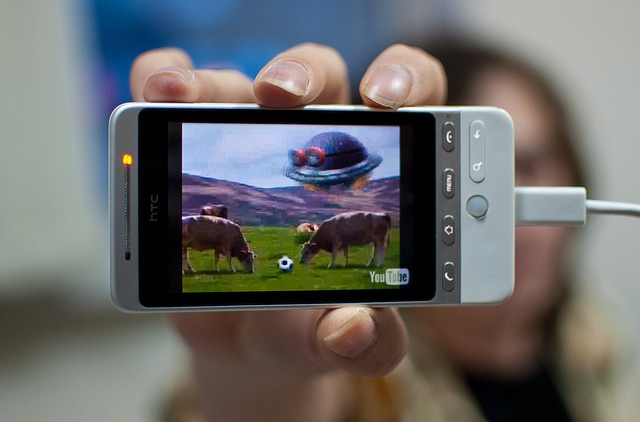Describe the objects in this image and their specific colors. I can see people in darkgray, maroon, gray, and black tones, cell phone in darkgray, black, gray, and darkgreen tones, cow in darkgray, black, darkgreen, and gray tones, cow in darkgray, black, darkgreen, and gray tones, and cow in darkgray, black, darkgreen, and tan tones in this image. 